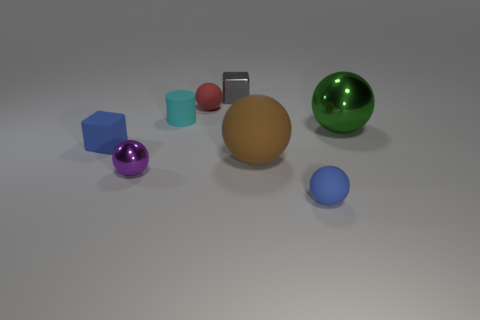Are there more gray shiny balls than green objects?
Make the answer very short. No. Do the blue cube and the small gray object have the same material?
Offer a very short reply. No. How many purple things are made of the same material as the gray block?
Your answer should be compact. 1. There is a green metallic ball; is its size the same as the brown object that is in front of the tiny cyan thing?
Provide a short and direct response. Yes. The small sphere that is on the left side of the small blue matte ball and on the right side of the small purple ball is what color?
Give a very brief answer. Red. Is there a cyan rubber cylinder that is behind the small blue matte thing right of the large brown sphere?
Your answer should be very brief. Yes. Are there the same number of cubes behind the tiny matte cylinder and large brown matte spheres?
Your answer should be very brief. Yes. There is a blue rubber object that is right of the tiny blue thing behind the big matte object; what number of big matte objects are in front of it?
Keep it short and to the point. 0. Is there a yellow rubber cylinder that has the same size as the blue rubber cube?
Your answer should be compact. No. Are there fewer blue rubber spheres behind the large matte sphere than gray metallic cubes?
Your answer should be compact. Yes. 